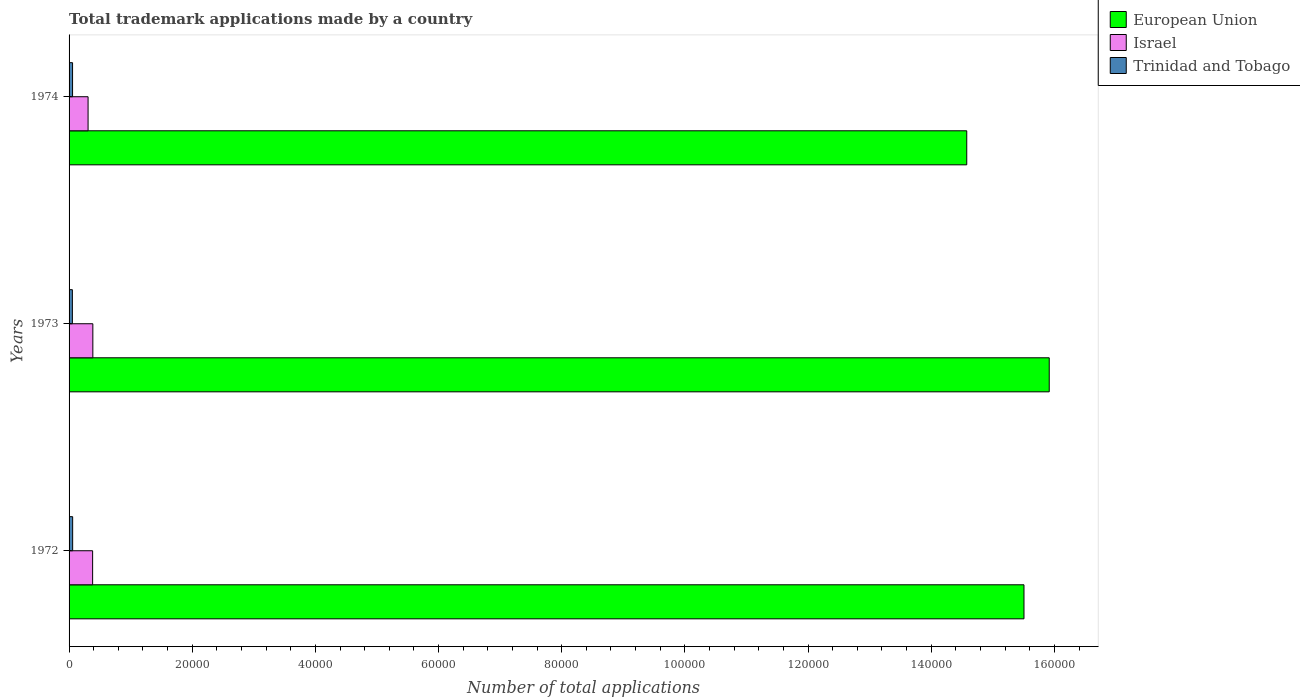How many groups of bars are there?
Keep it short and to the point. 3. How many bars are there on the 2nd tick from the top?
Provide a succinct answer. 3. How many bars are there on the 3rd tick from the bottom?
Provide a short and direct response. 3. What is the label of the 3rd group of bars from the top?
Ensure brevity in your answer.  1972. In how many cases, is the number of bars for a given year not equal to the number of legend labels?
Ensure brevity in your answer.  0. What is the number of applications made by in Israel in 1972?
Keep it short and to the point. 3824. Across all years, what is the maximum number of applications made by in European Union?
Keep it short and to the point. 1.59e+05. Across all years, what is the minimum number of applications made by in European Union?
Offer a terse response. 1.46e+05. In which year was the number of applications made by in European Union maximum?
Provide a succinct answer. 1973. In which year was the number of applications made by in European Union minimum?
Provide a short and direct response. 1974. What is the total number of applications made by in Trinidad and Tobago in the graph?
Keep it short and to the point. 1685. What is the difference between the number of applications made by in European Union in 1973 and the number of applications made by in Trinidad and Tobago in 1974?
Your answer should be very brief. 1.59e+05. What is the average number of applications made by in European Union per year?
Give a very brief answer. 1.53e+05. In the year 1972, what is the difference between the number of applications made by in Trinidad and Tobago and number of applications made by in Israel?
Keep it short and to the point. -3242. In how many years, is the number of applications made by in European Union greater than 80000 ?
Keep it short and to the point. 3. What is the ratio of the number of applications made by in Trinidad and Tobago in 1972 to that in 1973?
Keep it short and to the point. 1.09. What is the difference between the highest and the second highest number of applications made by in European Union?
Make the answer very short. 4099. What is the difference between the highest and the lowest number of applications made by in European Union?
Your answer should be compact. 1.34e+04. In how many years, is the number of applications made by in Israel greater than the average number of applications made by in Israel taken over all years?
Provide a short and direct response. 2. Is the sum of the number of applications made by in European Union in 1972 and 1974 greater than the maximum number of applications made by in Trinidad and Tobago across all years?
Ensure brevity in your answer.  Yes. What does the 2nd bar from the bottom in 1972 represents?
Your response must be concise. Israel. Is it the case that in every year, the sum of the number of applications made by in Trinidad and Tobago and number of applications made by in Israel is greater than the number of applications made by in European Union?
Keep it short and to the point. No. How many bars are there?
Provide a short and direct response. 9. Are all the bars in the graph horizontal?
Ensure brevity in your answer.  Yes. How many years are there in the graph?
Provide a succinct answer. 3. How many legend labels are there?
Offer a very short reply. 3. How are the legend labels stacked?
Keep it short and to the point. Vertical. What is the title of the graph?
Offer a very short reply. Total trademark applications made by a country. What is the label or title of the X-axis?
Give a very brief answer. Number of total applications. What is the Number of total applications of European Union in 1972?
Offer a very short reply. 1.55e+05. What is the Number of total applications of Israel in 1972?
Provide a succinct answer. 3824. What is the Number of total applications of Trinidad and Tobago in 1972?
Your answer should be very brief. 582. What is the Number of total applications of European Union in 1973?
Offer a very short reply. 1.59e+05. What is the Number of total applications of Israel in 1973?
Ensure brevity in your answer.  3860. What is the Number of total applications in Trinidad and Tobago in 1973?
Provide a short and direct response. 536. What is the Number of total applications of European Union in 1974?
Provide a short and direct response. 1.46e+05. What is the Number of total applications of Israel in 1974?
Make the answer very short. 3086. What is the Number of total applications of Trinidad and Tobago in 1974?
Make the answer very short. 567. Across all years, what is the maximum Number of total applications in European Union?
Provide a short and direct response. 1.59e+05. Across all years, what is the maximum Number of total applications in Israel?
Ensure brevity in your answer.  3860. Across all years, what is the maximum Number of total applications in Trinidad and Tobago?
Your response must be concise. 582. Across all years, what is the minimum Number of total applications in European Union?
Offer a very short reply. 1.46e+05. Across all years, what is the minimum Number of total applications of Israel?
Give a very brief answer. 3086. Across all years, what is the minimum Number of total applications of Trinidad and Tobago?
Provide a succinct answer. 536. What is the total Number of total applications of European Union in the graph?
Offer a very short reply. 4.60e+05. What is the total Number of total applications in Israel in the graph?
Make the answer very short. 1.08e+04. What is the total Number of total applications in Trinidad and Tobago in the graph?
Keep it short and to the point. 1685. What is the difference between the Number of total applications of European Union in 1972 and that in 1973?
Ensure brevity in your answer.  -4099. What is the difference between the Number of total applications in Israel in 1972 and that in 1973?
Your answer should be compact. -36. What is the difference between the Number of total applications in Trinidad and Tobago in 1972 and that in 1973?
Your answer should be very brief. 46. What is the difference between the Number of total applications of European Union in 1972 and that in 1974?
Your answer should be very brief. 9295. What is the difference between the Number of total applications in Israel in 1972 and that in 1974?
Offer a terse response. 738. What is the difference between the Number of total applications of Trinidad and Tobago in 1972 and that in 1974?
Keep it short and to the point. 15. What is the difference between the Number of total applications in European Union in 1973 and that in 1974?
Give a very brief answer. 1.34e+04. What is the difference between the Number of total applications of Israel in 1973 and that in 1974?
Ensure brevity in your answer.  774. What is the difference between the Number of total applications in Trinidad and Tobago in 1973 and that in 1974?
Make the answer very short. -31. What is the difference between the Number of total applications of European Union in 1972 and the Number of total applications of Israel in 1973?
Offer a very short reply. 1.51e+05. What is the difference between the Number of total applications of European Union in 1972 and the Number of total applications of Trinidad and Tobago in 1973?
Provide a short and direct response. 1.55e+05. What is the difference between the Number of total applications in Israel in 1972 and the Number of total applications in Trinidad and Tobago in 1973?
Your answer should be compact. 3288. What is the difference between the Number of total applications in European Union in 1972 and the Number of total applications in Israel in 1974?
Offer a very short reply. 1.52e+05. What is the difference between the Number of total applications of European Union in 1972 and the Number of total applications of Trinidad and Tobago in 1974?
Keep it short and to the point. 1.55e+05. What is the difference between the Number of total applications of Israel in 1972 and the Number of total applications of Trinidad and Tobago in 1974?
Offer a very short reply. 3257. What is the difference between the Number of total applications of European Union in 1973 and the Number of total applications of Israel in 1974?
Give a very brief answer. 1.56e+05. What is the difference between the Number of total applications in European Union in 1973 and the Number of total applications in Trinidad and Tobago in 1974?
Your response must be concise. 1.59e+05. What is the difference between the Number of total applications in Israel in 1973 and the Number of total applications in Trinidad and Tobago in 1974?
Give a very brief answer. 3293. What is the average Number of total applications in European Union per year?
Offer a terse response. 1.53e+05. What is the average Number of total applications of Israel per year?
Your answer should be very brief. 3590. What is the average Number of total applications in Trinidad and Tobago per year?
Your answer should be very brief. 561.67. In the year 1972, what is the difference between the Number of total applications of European Union and Number of total applications of Israel?
Keep it short and to the point. 1.51e+05. In the year 1972, what is the difference between the Number of total applications of European Union and Number of total applications of Trinidad and Tobago?
Give a very brief answer. 1.54e+05. In the year 1972, what is the difference between the Number of total applications of Israel and Number of total applications of Trinidad and Tobago?
Make the answer very short. 3242. In the year 1973, what is the difference between the Number of total applications in European Union and Number of total applications in Israel?
Your response must be concise. 1.55e+05. In the year 1973, what is the difference between the Number of total applications of European Union and Number of total applications of Trinidad and Tobago?
Ensure brevity in your answer.  1.59e+05. In the year 1973, what is the difference between the Number of total applications of Israel and Number of total applications of Trinidad and Tobago?
Ensure brevity in your answer.  3324. In the year 1974, what is the difference between the Number of total applications of European Union and Number of total applications of Israel?
Keep it short and to the point. 1.43e+05. In the year 1974, what is the difference between the Number of total applications in European Union and Number of total applications in Trinidad and Tobago?
Your answer should be compact. 1.45e+05. In the year 1974, what is the difference between the Number of total applications in Israel and Number of total applications in Trinidad and Tobago?
Ensure brevity in your answer.  2519. What is the ratio of the Number of total applications of European Union in 1972 to that in 1973?
Ensure brevity in your answer.  0.97. What is the ratio of the Number of total applications of Trinidad and Tobago in 1972 to that in 1973?
Ensure brevity in your answer.  1.09. What is the ratio of the Number of total applications of European Union in 1972 to that in 1974?
Offer a very short reply. 1.06. What is the ratio of the Number of total applications of Israel in 1972 to that in 1974?
Offer a terse response. 1.24. What is the ratio of the Number of total applications in Trinidad and Tobago in 1972 to that in 1974?
Keep it short and to the point. 1.03. What is the ratio of the Number of total applications in European Union in 1973 to that in 1974?
Ensure brevity in your answer.  1.09. What is the ratio of the Number of total applications of Israel in 1973 to that in 1974?
Ensure brevity in your answer.  1.25. What is the ratio of the Number of total applications of Trinidad and Tobago in 1973 to that in 1974?
Make the answer very short. 0.95. What is the difference between the highest and the second highest Number of total applications in European Union?
Your answer should be very brief. 4099. What is the difference between the highest and the lowest Number of total applications of European Union?
Keep it short and to the point. 1.34e+04. What is the difference between the highest and the lowest Number of total applications in Israel?
Offer a very short reply. 774. 